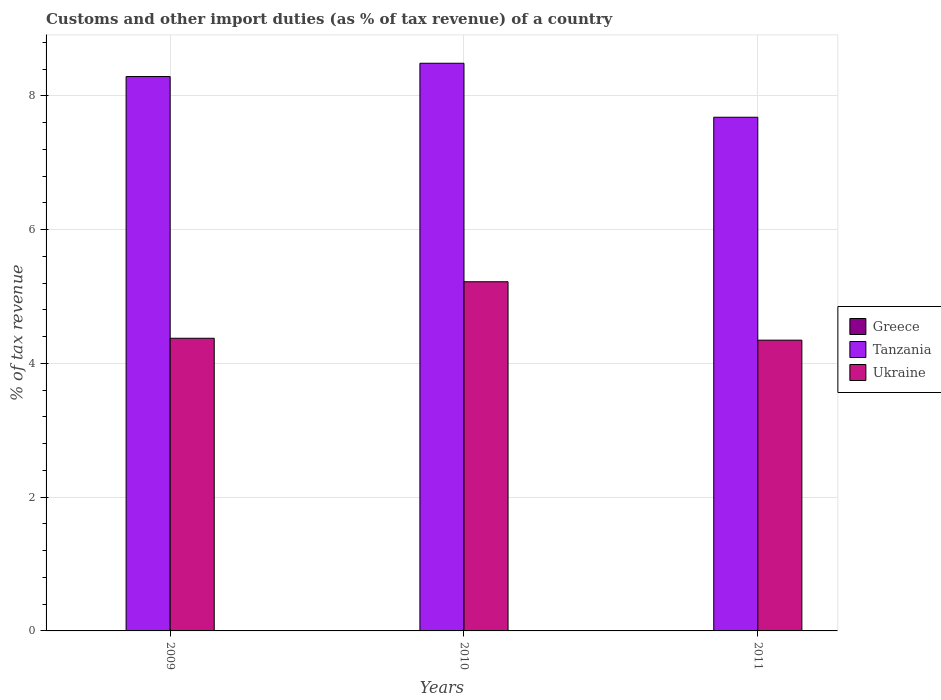How many different coloured bars are there?
Make the answer very short. 3. How many groups of bars are there?
Your answer should be compact. 3. Are the number of bars per tick equal to the number of legend labels?
Give a very brief answer. Yes. How many bars are there on the 3rd tick from the left?
Ensure brevity in your answer.  3. How many bars are there on the 1st tick from the right?
Ensure brevity in your answer.  3. What is the label of the 2nd group of bars from the left?
Provide a short and direct response. 2010. In how many cases, is the number of bars for a given year not equal to the number of legend labels?
Offer a very short reply. 0. What is the percentage of tax revenue from customs in Ukraine in 2010?
Your answer should be very brief. 5.22. Across all years, what is the maximum percentage of tax revenue from customs in Ukraine?
Your answer should be very brief. 5.22. Across all years, what is the minimum percentage of tax revenue from customs in Greece?
Provide a succinct answer. 0. In which year was the percentage of tax revenue from customs in Tanzania maximum?
Your response must be concise. 2010. In which year was the percentage of tax revenue from customs in Greece minimum?
Your response must be concise. 2009. What is the total percentage of tax revenue from customs in Greece in the graph?
Your response must be concise. 0.01. What is the difference between the percentage of tax revenue from customs in Ukraine in 2009 and that in 2010?
Your response must be concise. -0.84. What is the difference between the percentage of tax revenue from customs in Greece in 2011 and the percentage of tax revenue from customs in Ukraine in 2010?
Offer a very short reply. -5.22. What is the average percentage of tax revenue from customs in Ukraine per year?
Your answer should be compact. 4.65. In the year 2009, what is the difference between the percentage of tax revenue from customs in Tanzania and percentage of tax revenue from customs in Ukraine?
Your response must be concise. 3.91. What is the ratio of the percentage of tax revenue from customs in Ukraine in 2010 to that in 2011?
Make the answer very short. 1.2. Is the percentage of tax revenue from customs in Ukraine in 2010 less than that in 2011?
Give a very brief answer. No. Is the difference between the percentage of tax revenue from customs in Tanzania in 2010 and 2011 greater than the difference between the percentage of tax revenue from customs in Ukraine in 2010 and 2011?
Provide a succinct answer. No. What is the difference between the highest and the second highest percentage of tax revenue from customs in Tanzania?
Offer a terse response. 0.2. What is the difference between the highest and the lowest percentage of tax revenue from customs in Greece?
Your response must be concise. 0. In how many years, is the percentage of tax revenue from customs in Ukraine greater than the average percentage of tax revenue from customs in Ukraine taken over all years?
Keep it short and to the point. 1. What does the 2nd bar from the left in 2011 represents?
Provide a short and direct response. Tanzania. What does the 1st bar from the right in 2009 represents?
Ensure brevity in your answer.  Ukraine. Is it the case that in every year, the sum of the percentage of tax revenue from customs in Ukraine and percentage of tax revenue from customs in Greece is greater than the percentage of tax revenue from customs in Tanzania?
Offer a very short reply. No. What is the difference between two consecutive major ticks on the Y-axis?
Your answer should be very brief. 2. Are the values on the major ticks of Y-axis written in scientific E-notation?
Offer a very short reply. No. Does the graph contain any zero values?
Keep it short and to the point. No. Does the graph contain grids?
Make the answer very short. Yes. How are the legend labels stacked?
Provide a succinct answer. Vertical. What is the title of the graph?
Your answer should be very brief. Customs and other import duties (as % of tax revenue) of a country. What is the label or title of the Y-axis?
Give a very brief answer. % of tax revenue. What is the % of tax revenue of Greece in 2009?
Your response must be concise. 0. What is the % of tax revenue in Tanzania in 2009?
Your response must be concise. 8.29. What is the % of tax revenue of Ukraine in 2009?
Your response must be concise. 4.38. What is the % of tax revenue in Greece in 2010?
Keep it short and to the point. 0. What is the % of tax revenue in Tanzania in 2010?
Your answer should be compact. 8.49. What is the % of tax revenue in Ukraine in 2010?
Provide a short and direct response. 5.22. What is the % of tax revenue of Greece in 2011?
Keep it short and to the point. 0. What is the % of tax revenue of Tanzania in 2011?
Keep it short and to the point. 7.68. What is the % of tax revenue in Ukraine in 2011?
Provide a short and direct response. 4.35. Across all years, what is the maximum % of tax revenue in Greece?
Your response must be concise. 0. Across all years, what is the maximum % of tax revenue of Tanzania?
Make the answer very short. 8.49. Across all years, what is the maximum % of tax revenue of Ukraine?
Provide a succinct answer. 5.22. Across all years, what is the minimum % of tax revenue in Greece?
Your response must be concise. 0. Across all years, what is the minimum % of tax revenue in Tanzania?
Give a very brief answer. 7.68. Across all years, what is the minimum % of tax revenue in Ukraine?
Provide a short and direct response. 4.35. What is the total % of tax revenue of Greece in the graph?
Give a very brief answer. 0.01. What is the total % of tax revenue in Tanzania in the graph?
Your answer should be compact. 24.45. What is the total % of tax revenue of Ukraine in the graph?
Your answer should be compact. 13.94. What is the difference between the % of tax revenue in Greece in 2009 and that in 2010?
Ensure brevity in your answer.  -0. What is the difference between the % of tax revenue of Tanzania in 2009 and that in 2010?
Provide a succinct answer. -0.2. What is the difference between the % of tax revenue of Ukraine in 2009 and that in 2010?
Provide a succinct answer. -0.84. What is the difference between the % of tax revenue of Greece in 2009 and that in 2011?
Ensure brevity in your answer.  -0. What is the difference between the % of tax revenue in Tanzania in 2009 and that in 2011?
Offer a terse response. 0.61. What is the difference between the % of tax revenue in Ukraine in 2009 and that in 2011?
Give a very brief answer. 0.03. What is the difference between the % of tax revenue in Greece in 2010 and that in 2011?
Your answer should be compact. -0. What is the difference between the % of tax revenue in Tanzania in 2010 and that in 2011?
Give a very brief answer. 0.81. What is the difference between the % of tax revenue in Ukraine in 2010 and that in 2011?
Ensure brevity in your answer.  0.87. What is the difference between the % of tax revenue in Greece in 2009 and the % of tax revenue in Tanzania in 2010?
Provide a short and direct response. -8.48. What is the difference between the % of tax revenue of Greece in 2009 and the % of tax revenue of Ukraine in 2010?
Give a very brief answer. -5.22. What is the difference between the % of tax revenue in Tanzania in 2009 and the % of tax revenue in Ukraine in 2010?
Give a very brief answer. 3.07. What is the difference between the % of tax revenue in Greece in 2009 and the % of tax revenue in Tanzania in 2011?
Your answer should be compact. -7.68. What is the difference between the % of tax revenue in Greece in 2009 and the % of tax revenue in Ukraine in 2011?
Ensure brevity in your answer.  -4.34. What is the difference between the % of tax revenue of Tanzania in 2009 and the % of tax revenue of Ukraine in 2011?
Give a very brief answer. 3.94. What is the difference between the % of tax revenue in Greece in 2010 and the % of tax revenue in Tanzania in 2011?
Make the answer very short. -7.68. What is the difference between the % of tax revenue of Greece in 2010 and the % of tax revenue of Ukraine in 2011?
Ensure brevity in your answer.  -4.34. What is the difference between the % of tax revenue of Tanzania in 2010 and the % of tax revenue of Ukraine in 2011?
Offer a very short reply. 4.14. What is the average % of tax revenue of Greece per year?
Your answer should be compact. 0. What is the average % of tax revenue in Tanzania per year?
Ensure brevity in your answer.  8.15. What is the average % of tax revenue of Ukraine per year?
Make the answer very short. 4.65. In the year 2009, what is the difference between the % of tax revenue of Greece and % of tax revenue of Tanzania?
Offer a terse response. -8.29. In the year 2009, what is the difference between the % of tax revenue in Greece and % of tax revenue in Ukraine?
Your answer should be compact. -4.37. In the year 2009, what is the difference between the % of tax revenue of Tanzania and % of tax revenue of Ukraine?
Your response must be concise. 3.91. In the year 2010, what is the difference between the % of tax revenue of Greece and % of tax revenue of Tanzania?
Your answer should be compact. -8.48. In the year 2010, what is the difference between the % of tax revenue of Greece and % of tax revenue of Ukraine?
Offer a terse response. -5.22. In the year 2010, what is the difference between the % of tax revenue of Tanzania and % of tax revenue of Ukraine?
Provide a succinct answer. 3.27. In the year 2011, what is the difference between the % of tax revenue in Greece and % of tax revenue in Tanzania?
Provide a succinct answer. -7.68. In the year 2011, what is the difference between the % of tax revenue in Greece and % of tax revenue in Ukraine?
Provide a short and direct response. -4.34. In the year 2011, what is the difference between the % of tax revenue in Tanzania and % of tax revenue in Ukraine?
Your response must be concise. 3.33. What is the ratio of the % of tax revenue of Greece in 2009 to that in 2010?
Offer a very short reply. 0.98. What is the ratio of the % of tax revenue of Tanzania in 2009 to that in 2010?
Keep it short and to the point. 0.98. What is the ratio of the % of tax revenue of Ukraine in 2009 to that in 2010?
Provide a short and direct response. 0.84. What is the ratio of the % of tax revenue of Greece in 2009 to that in 2011?
Offer a terse response. 0.49. What is the ratio of the % of tax revenue in Tanzania in 2009 to that in 2011?
Make the answer very short. 1.08. What is the ratio of the % of tax revenue in Greece in 2010 to that in 2011?
Offer a very short reply. 0.5. What is the ratio of the % of tax revenue in Tanzania in 2010 to that in 2011?
Your answer should be very brief. 1.11. What is the ratio of the % of tax revenue in Ukraine in 2010 to that in 2011?
Keep it short and to the point. 1.2. What is the difference between the highest and the second highest % of tax revenue in Greece?
Offer a terse response. 0. What is the difference between the highest and the second highest % of tax revenue in Tanzania?
Provide a short and direct response. 0.2. What is the difference between the highest and the second highest % of tax revenue in Ukraine?
Make the answer very short. 0.84. What is the difference between the highest and the lowest % of tax revenue of Greece?
Provide a short and direct response. 0. What is the difference between the highest and the lowest % of tax revenue of Tanzania?
Make the answer very short. 0.81. What is the difference between the highest and the lowest % of tax revenue in Ukraine?
Your answer should be compact. 0.87. 